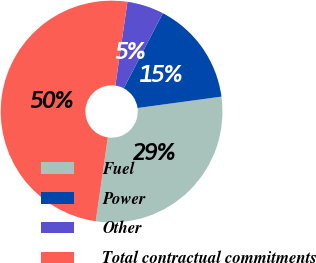Convert chart to OTSL. <chart><loc_0><loc_0><loc_500><loc_500><pie_chart><fcel>Fuel<fcel>Power<fcel>Other<fcel>Total contractual commitments<nl><fcel>29.43%<fcel>15.2%<fcel>5.37%<fcel>50.0%<nl></chart> 